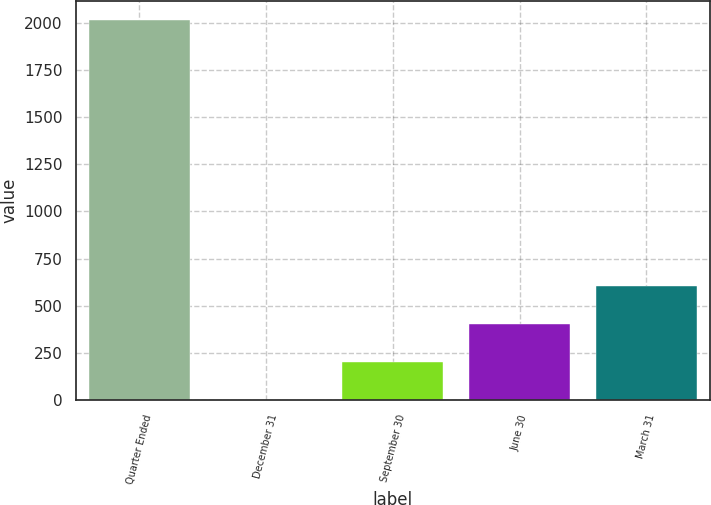<chart> <loc_0><loc_0><loc_500><loc_500><bar_chart><fcel>Quarter Ended<fcel>December 31<fcel>September 30<fcel>June 30<fcel>March 31<nl><fcel>2013<fcel>0.24<fcel>201.52<fcel>402.8<fcel>604.08<nl></chart> 